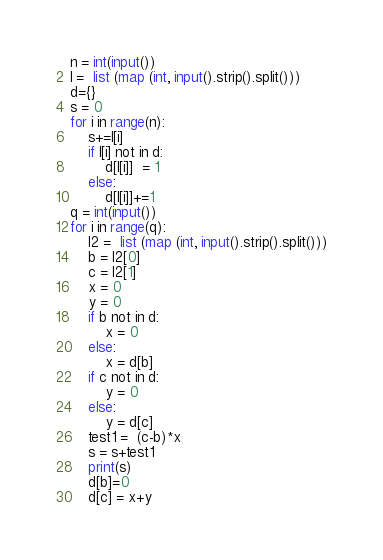Convert code to text. <code><loc_0><loc_0><loc_500><loc_500><_Python_>n = int(input())
l =  list (map (int, input().strip().split()))
d={}
s = 0
for i in range(n):
    s+=l[i]
    if l[i] not in d:
        d[l[i]]  = 1 
    else:
        d[l[i]]+=1 
q = int(input())
for i in range(q):
    l2 =  list (map (int, input().strip().split()))
    b = l2[0]
    c = l2[1]
    x = 0
    y = 0
    if b not in d:
        x = 0
    else:
        x = d[b]
    if c not in d:
        y = 0
    else:
        y = d[c]
    test1 =  (c-b)*x
    s = s+test1
    print(s)
    d[b]=0
    d[c] = x+y</code> 